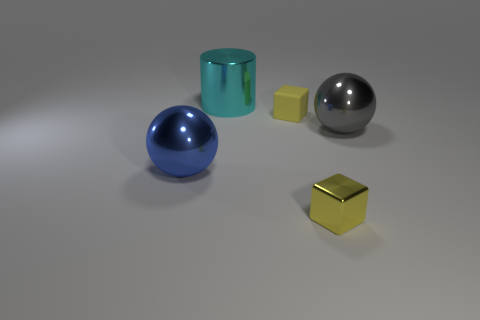Add 2 yellow shiny cubes. How many objects exist? 7 Subtract all blocks. How many objects are left? 3 Add 2 big blue shiny spheres. How many big blue shiny spheres are left? 3 Add 2 balls. How many balls exist? 4 Subtract 0 red balls. How many objects are left? 5 Subtract all tiny yellow metal objects. Subtract all blue things. How many objects are left? 3 